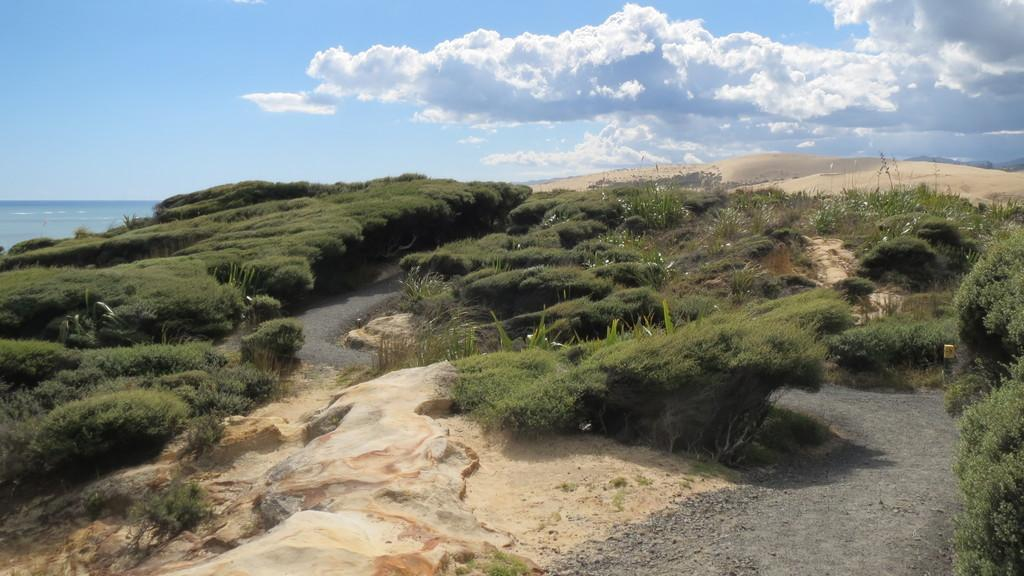What type of vegetation is present in the image? There is grass and plants in the image. What else can be seen on the ground in the image? There are other objects on the ground in the image. What is visible in the background of the image? The sky and water are visible in the background of the image. How many boys are holding the quilt in the image? There are no boys or quilts present in the image. What color is the nose of the person in the image? There is no person or nose visible in the image. 